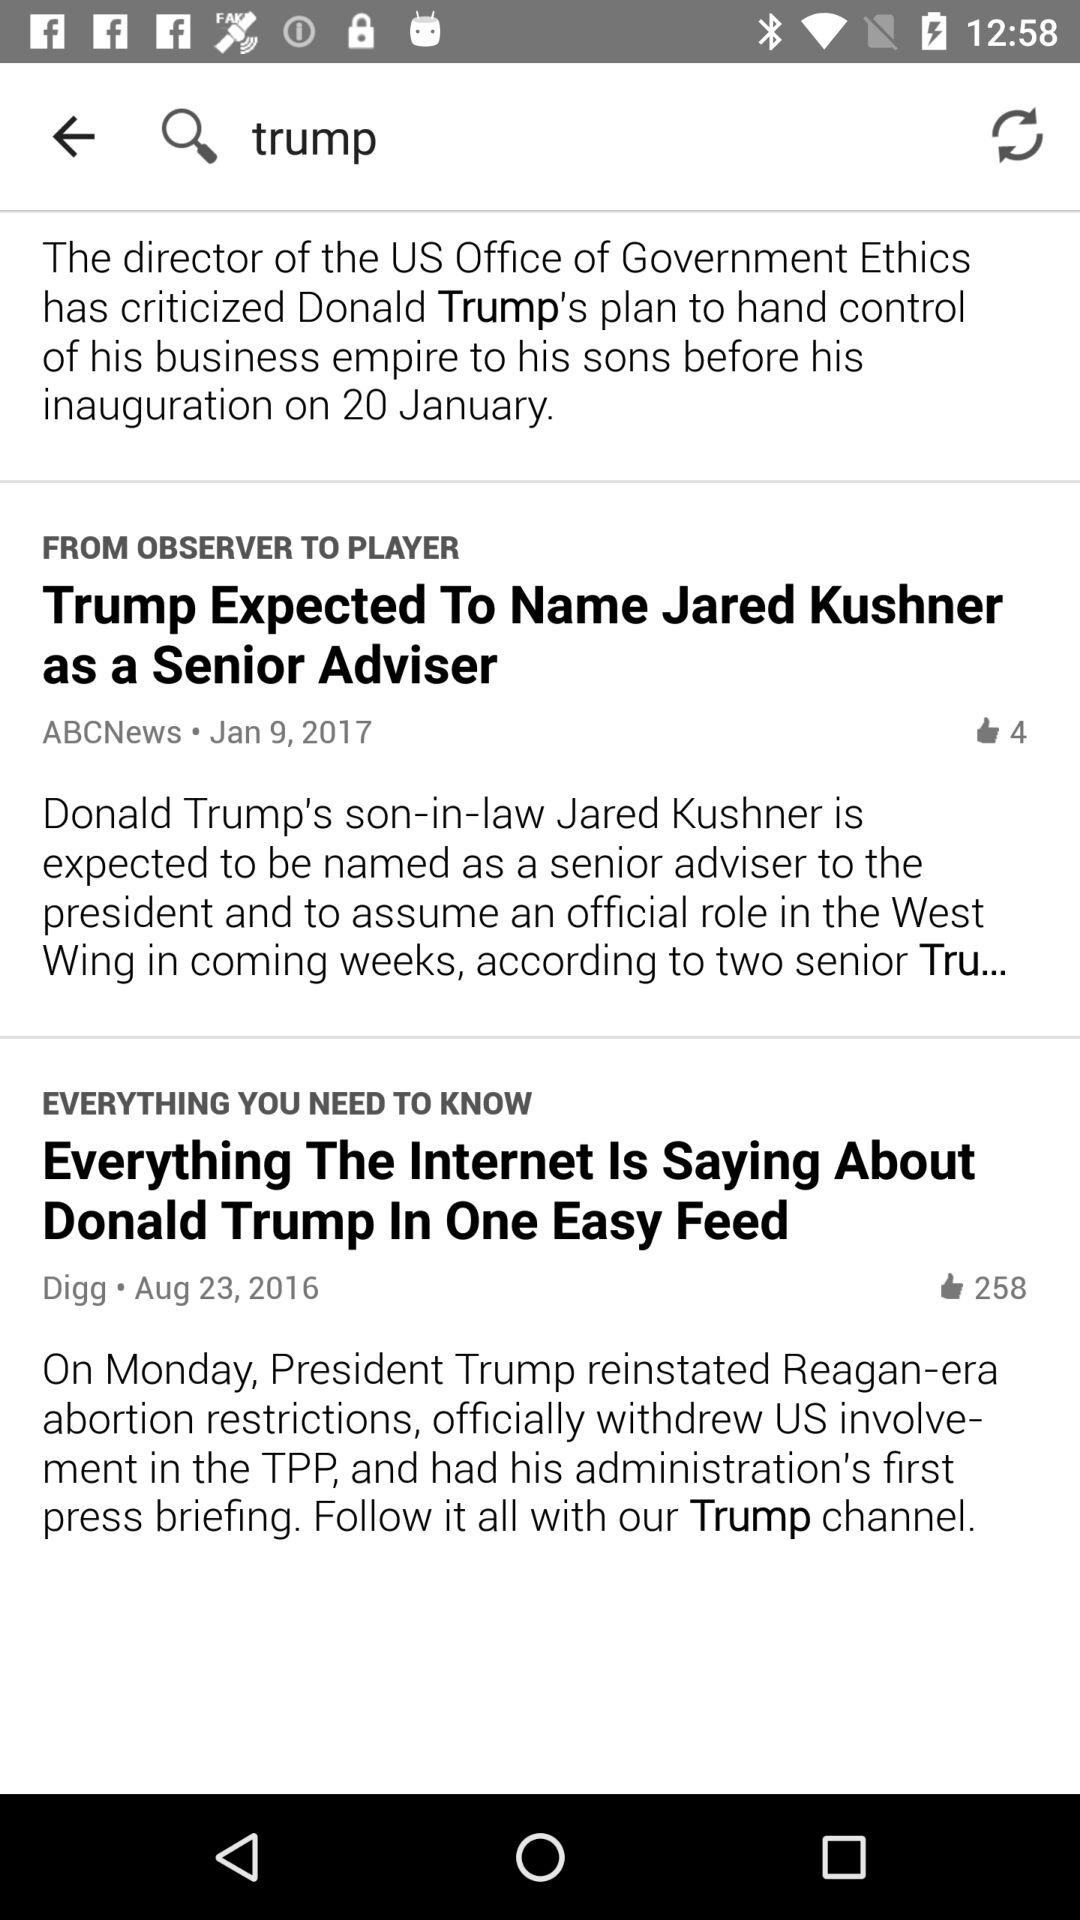When was the news posted by ABCNews? The news was posted on January 9, 2017. 